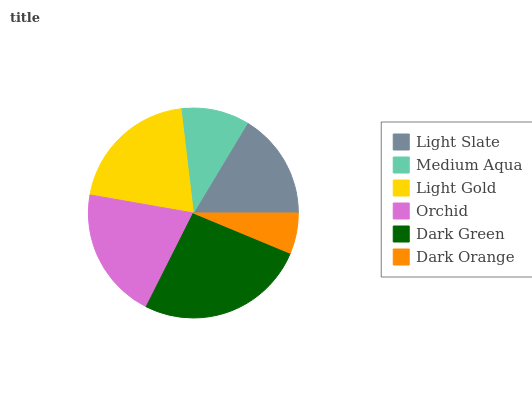Is Dark Orange the minimum?
Answer yes or no. Yes. Is Dark Green the maximum?
Answer yes or no. Yes. Is Medium Aqua the minimum?
Answer yes or no. No. Is Medium Aqua the maximum?
Answer yes or no. No. Is Light Slate greater than Medium Aqua?
Answer yes or no. Yes. Is Medium Aqua less than Light Slate?
Answer yes or no. Yes. Is Medium Aqua greater than Light Slate?
Answer yes or no. No. Is Light Slate less than Medium Aqua?
Answer yes or no. No. Is Orchid the high median?
Answer yes or no. Yes. Is Light Slate the low median?
Answer yes or no. Yes. Is Dark Orange the high median?
Answer yes or no. No. Is Orchid the low median?
Answer yes or no. No. 